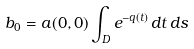<formula> <loc_0><loc_0><loc_500><loc_500>b _ { 0 } = a ( 0 , 0 ) \int _ { D } e ^ { - q ( t ) } \, d t \, d s</formula> 